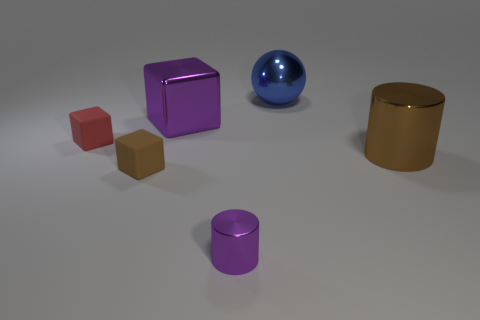There is a tiny red object that is to the left of the brown metal object; is its shape the same as the large blue thing?
Provide a succinct answer. No. There is a cylinder on the right side of the purple cylinder; what material is it?
Offer a terse response. Metal. How many large blue metallic things are the same shape as the large purple shiny thing?
Make the answer very short. 0. What material is the purple object that is in front of the big metallic thing that is on the right side of the large blue ball made of?
Ensure brevity in your answer.  Metal. The thing that is the same color as the big metallic block is what shape?
Keep it short and to the point. Cylinder. Is there a big thing that has the same material as the blue sphere?
Your response must be concise. Yes. What is the shape of the brown metal object?
Offer a terse response. Cylinder. How many small purple things are there?
Your answer should be compact. 1. The matte object to the left of the brown object left of the purple shiny cube is what color?
Offer a terse response. Red. There is a metallic cube that is the same size as the ball; what is its color?
Give a very brief answer. Purple. 